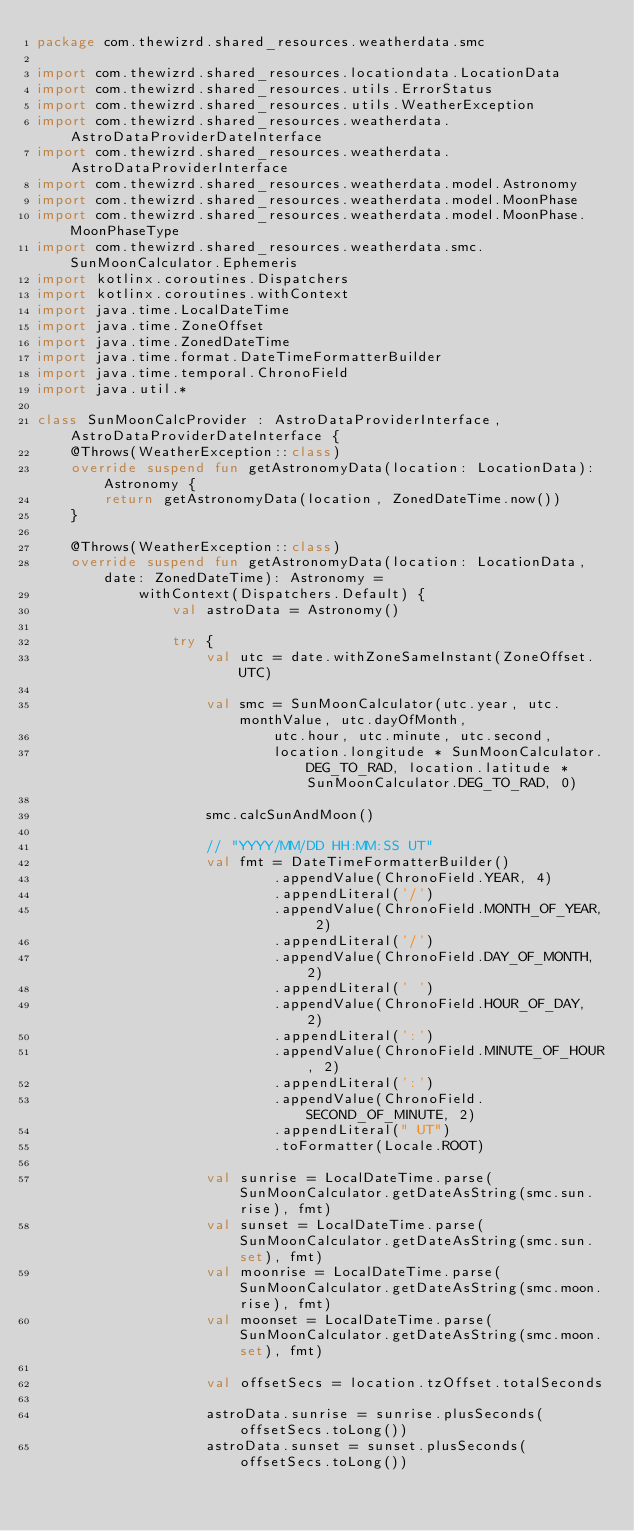<code> <loc_0><loc_0><loc_500><loc_500><_Kotlin_>package com.thewizrd.shared_resources.weatherdata.smc

import com.thewizrd.shared_resources.locationdata.LocationData
import com.thewizrd.shared_resources.utils.ErrorStatus
import com.thewizrd.shared_resources.utils.WeatherException
import com.thewizrd.shared_resources.weatherdata.AstroDataProviderDateInterface
import com.thewizrd.shared_resources.weatherdata.AstroDataProviderInterface
import com.thewizrd.shared_resources.weatherdata.model.Astronomy
import com.thewizrd.shared_resources.weatherdata.model.MoonPhase
import com.thewizrd.shared_resources.weatherdata.model.MoonPhase.MoonPhaseType
import com.thewizrd.shared_resources.weatherdata.smc.SunMoonCalculator.Ephemeris
import kotlinx.coroutines.Dispatchers
import kotlinx.coroutines.withContext
import java.time.LocalDateTime
import java.time.ZoneOffset
import java.time.ZonedDateTime
import java.time.format.DateTimeFormatterBuilder
import java.time.temporal.ChronoField
import java.util.*

class SunMoonCalcProvider : AstroDataProviderInterface, AstroDataProviderDateInterface {
    @Throws(WeatherException::class)
    override suspend fun getAstronomyData(location: LocationData): Astronomy {
        return getAstronomyData(location, ZonedDateTime.now())
    }

    @Throws(WeatherException::class)
    override suspend fun getAstronomyData(location: LocationData, date: ZonedDateTime): Astronomy =
            withContext(Dispatchers.Default) {
                val astroData = Astronomy()

                try {
                    val utc = date.withZoneSameInstant(ZoneOffset.UTC)

                    val smc = SunMoonCalculator(utc.year, utc.monthValue, utc.dayOfMonth,
                            utc.hour, utc.minute, utc.second,
                            location.longitude * SunMoonCalculator.DEG_TO_RAD, location.latitude * SunMoonCalculator.DEG_TO_RAD, 0)

                    smc.calcSunAndMoon()

                    // "YYYY/MM/DD HH:MM:SS UT"
                    val fmt = DateTimeFormatterBuilder()
                            .appendValue(ChronoField.YEAR, 4)
                            .appendLiteral('/')
                            .appendValue(ChronoField.MONTH_OF_YEAR, 2)
                            .appendLiteral('/')
                            .appendValue(ChronoField.DAY_OF_MONTH, 2)
                            .appendLiteral(' ')
                            .appendValue(ChronoField.HOUR_OF_DAY, 2)
                            .appendLiteral(':')
                            .appendValue(ChronoField.MINUTE_OF_HOUR, 2)
                            .appendLiteral(':')
                            .appendValue(ChronoField.SECOND_OF_MINUTE, 2)
                            .appendLiteral(" UT")
                            .toFormatter(Locale.ROOT)

                    val sunrise = LocalDateTime.parse(SunMoonCalculator.getDateAsString(smc.sun.rise), fmt)
                    val sunset = LocalDateTime.parse(SunMoonCalculator.getDateAsString(smc.sun.set), fmt)
                    val moonrise = LocalDateTime.parse(SunMoonCalculator.getDateAsString(smc.moon.rise), fmt)
                    val moonset = LocalDateTime.parse(SunMoonCalculator.getDateAsString(smc.moon.set), fmt)

                    val offsetSecs = location.tzOffset.totalSeconds

                    astroData.sunrise = sunrise.plusSeconds(offsetSecs.toLong())
                    astroData.sunset = sunset.plusSeconds(offsetSecs.toLong())</code> 